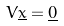<formula> <loc_0><loc_0><loc_500><loc_500>V \underline { x } = \underline { 0 }</formula> 